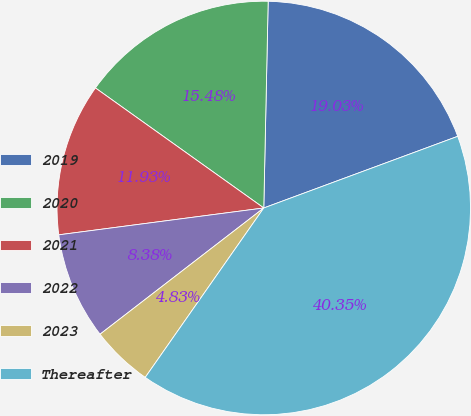Convert chart to OTSL. <chart><loc_0><loc_0><loc_500><loc_500><pie_chart><fcel>2019<fcel>2020<fcel>2021<fcel>2022<fcel>2023<fcel>Thereafter<nl><fcel>19.03%<fcel>15.48%<fcel>11.93%<fcel>8.38%<fcel>4.83%<fcel>40.35%<nl></chart> 